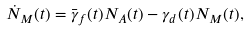<formula> <loc_0><loc_0><loc_500><loc_500>\dot { N } _ { M } ( t ) = \bar { \gamma } _ { f } ( t ) N _ { A } ( t ) - \gamma _ { d } ( t ) N _ { M } ( t ) ,</formula> 